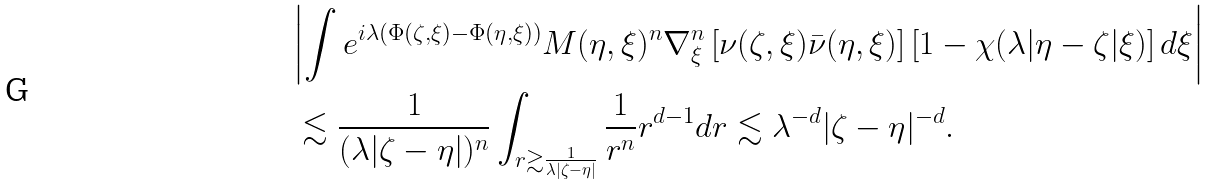Convert formula to latex. <formula><loc_0><loc_0><loc_500><loc_500>& \left | \int e ^ { i \lambda ( \Phi ( \zeta , \xi ) - \Phi ( \eta , \xi ) ) } M ( \eta , \xi ) ^ { n } \nabla ^ { n } _ { \xi } \left [ \nu ( \zeta , \xi ) \bar { \nu } ( \eta , \xi ) \right ] \left [ 1 - \chi ( \lambda | \eta - \zeta | \xi ) \right ] d \xi \right | \\ & \, \lesssim \frac { 1 } { ( \lambda | \zeta - \eta | ) ^ { n } } \int _ { r \gtrsim \frac { 1 } { \lambda | \zeta - \eta | } } \frac { 1 } { r ^ { n } } r ^ { d - 1 } d r \lesssim \lambda ^ { - d } | \zeta - \eta | ^ { - d } .</formula> 